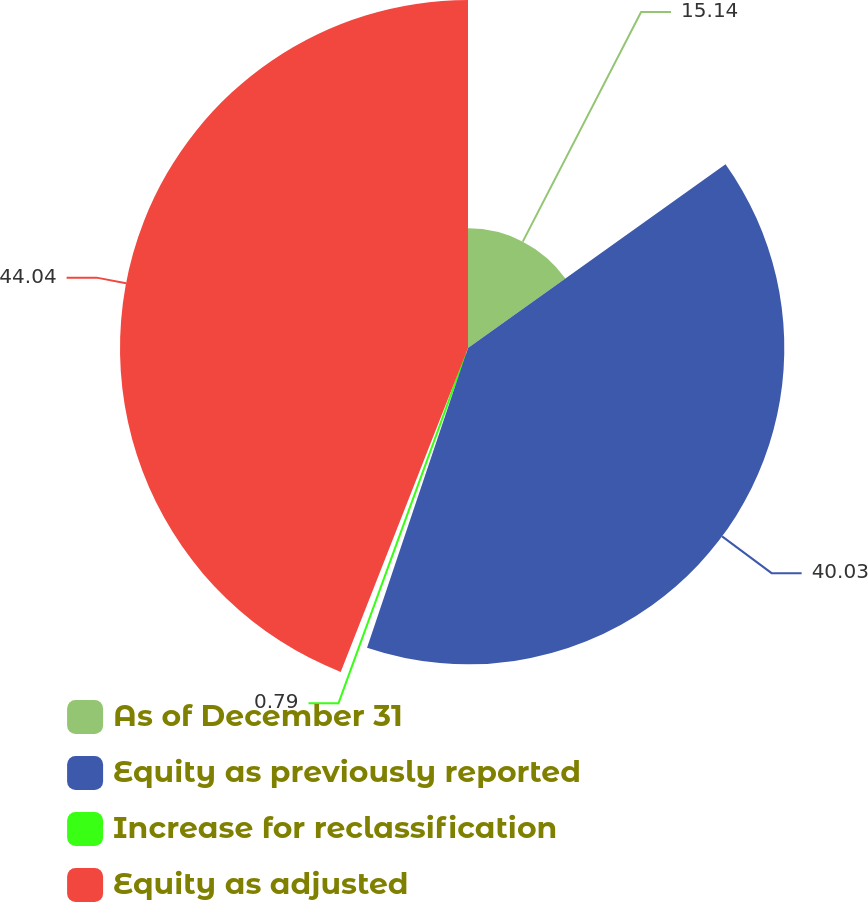<chart> <loc_0><loc_0><loc_500><loc_500><pie_chart><fcel>As of December 31<fcel>Equity as previously reported<fcel>Increase for reclassification<fcel>Equity as adjusted<nl><fcel>15.14%<fcel>40.03%<fcel>0.79%<fcel>44.04%<nl></chart> 